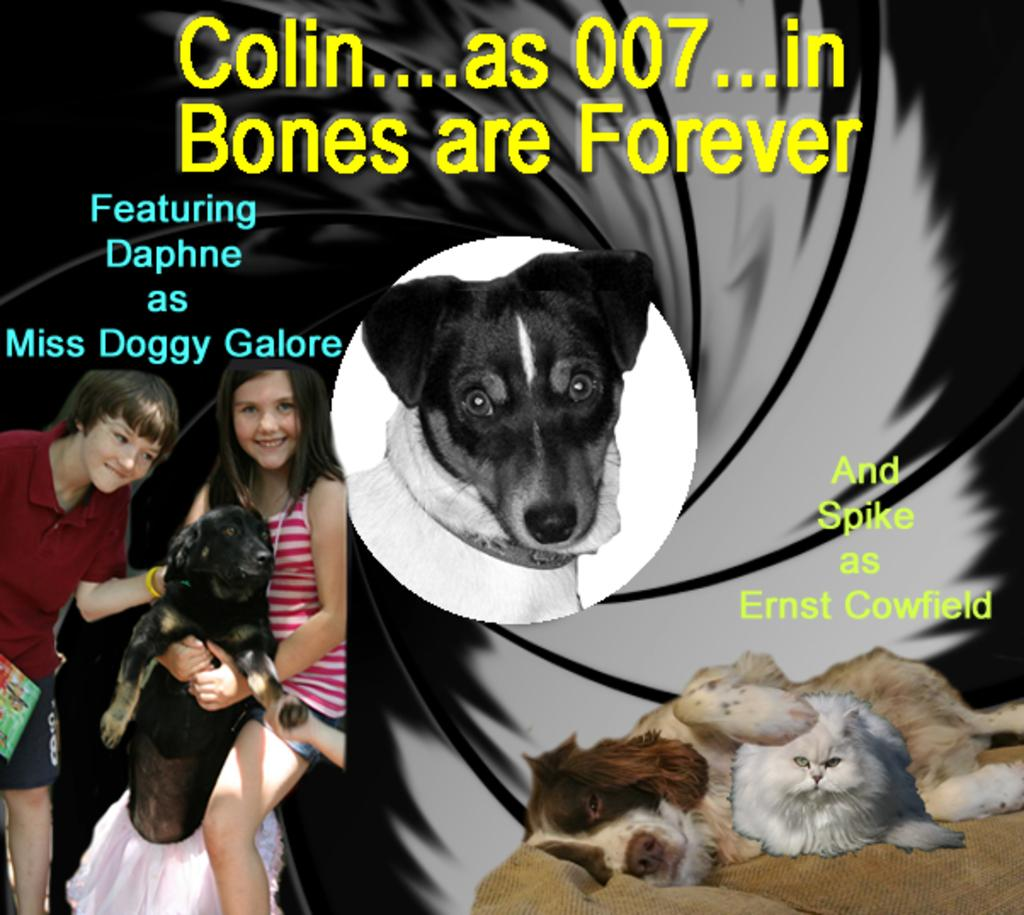What type of visual is the image? The image is a poster. What animals are featured in the poster? There are dogs in the poster. What are the people in the poster doing? There are two people smiling in the poster. What material is depicted in the poster? There is cloth depicted in the poster. What else can be found in the poster besides the images? There is text in the poster. Where is the spot where the dogs need to stretch in the poster? There is no spot where the dogs need to stretch in the poster, as the dogs are not depicted as performing any actions. 